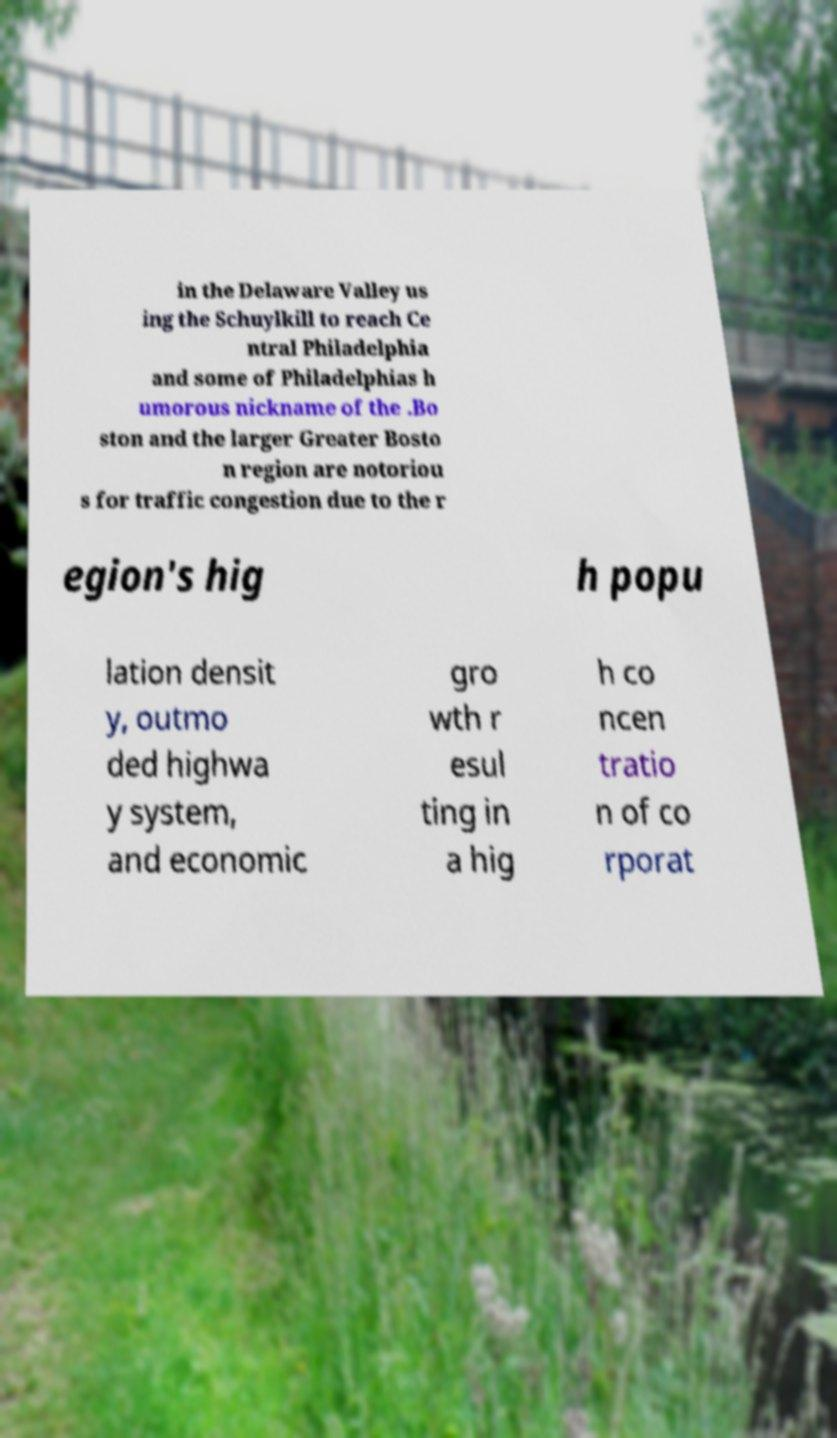Please identify and transcribe the text found in this image. in the Delaware Valley us ing the Schuylkill to reach Ce ntral Philadelphia and some of Philadelphias h umorous nickname of the .Bo ston and the larger Greater Bosto n region are notoriou s for traffic congestion due to the r egion's hig h popu lation densit y, outmo ded highwa y system, and economic gro wth r esul ting in a hig h co ncen tratio n of co rporat 